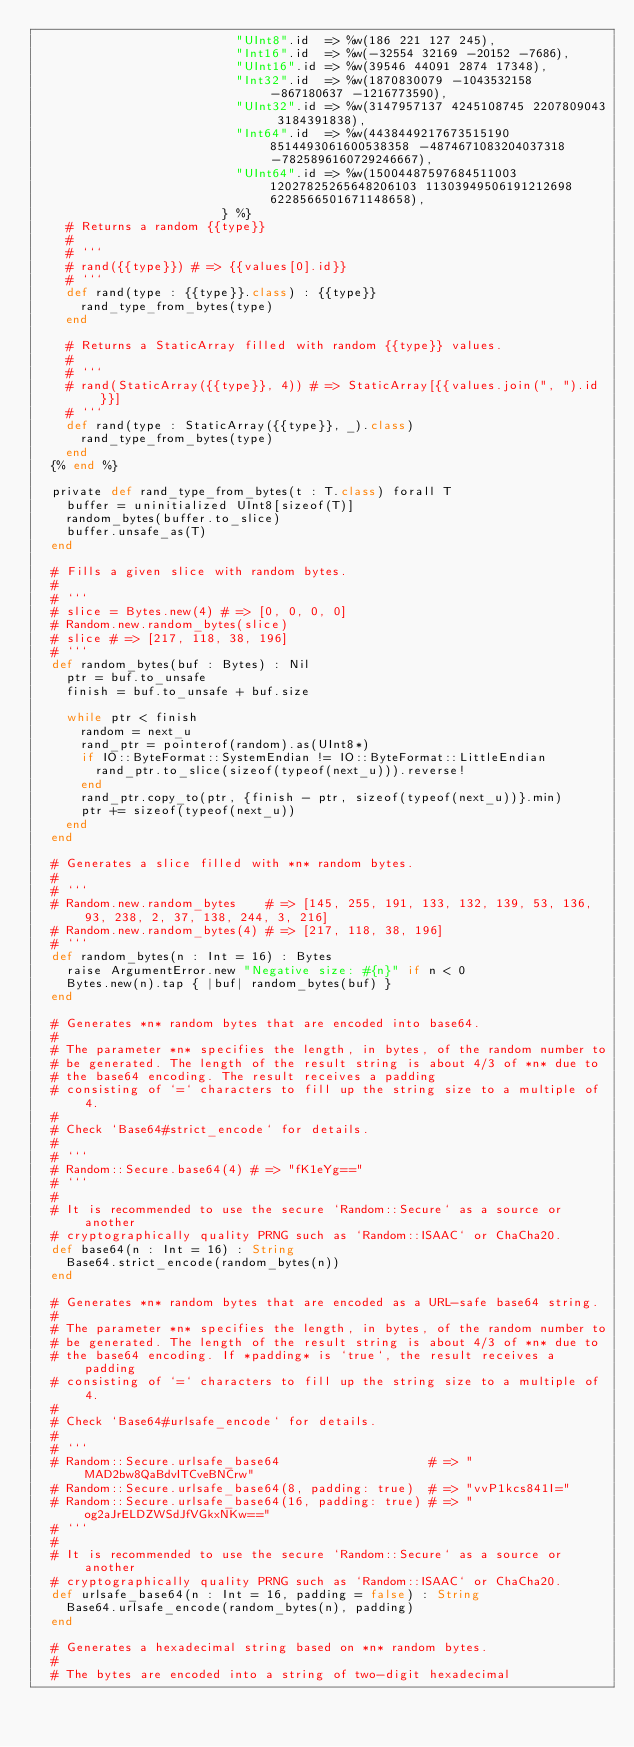<code> <loc_0><loc_0><loc_500><loc_500><_Crystal_>                           "UInt8".id  => %w(186 221 127 245),
                           "Int16".id  => %w(-32554 32169 -20152 -7686),
                           "UInt16".id => %w(39546 44091 2874 17348),
                           "Int32".id  => %w(1870830079 -1043532158 -867180637 -1216773590),
                           "UInt32".id => %w(3147957137 4245108745 2207809043 3184391838),
                           "Int64".id  => %w(4438449217673515190 8514493061600538358 -4874671083204037318 -7825896160729246667),
                           "UInt64".id => %w(15004487597684511003 12027825265648206103 11303949506191212698 6228566501671148658),
                         } %}
    # Returns a random {{type}}
    #
    # ```
    # rand({{type}}) # => {{values[0].id}}
    # ```
    def rand(type : {{type}}.class) : {{type}}
      rand_type_from_bytes(type)
    end

    # Returns a StaticArray filled with random {{type}} values.
    #
    # ```
    # rand(StaticArray({{type}}, 4)) # => StaticArray[{{values.join(", ").id}}]
    # ```
    def rand(type : StaticArray({{type}}, _).class)
      rand_type_from_bytes(type)
    end
  {% end %}

  private def rand_type_from_bytes(t : T.class) forall T
    buffer = uninitialized UInt8[sizeof(T)]
    random_bytes(buffer.to_slice)
    buffer.unsafe_as(T)
  end

  # Fills a given slice with random bytes.
  #
  # ```
  # slice = Bytes.new(4) # => [0, 0, 0, 0]
  # Random.new.random_bytes(slice)
  # slice # => [217, 118, 38, 196]
  # ```
  def random_bytes(buf : Bytes) : Nil
    ptr = buf.to_unsafe
    finish = buf.to_unsafe + buf.size

    while ptr < finish
      random = next_u
      rand_ptr = pointerof(random).as(UInt8*)
      if IO::ByteFormat::SystemEndian != IO::ByteFormat::LittleEndian
        rand_ptr.to_slice(sizeof(typeof(next_u))).reverse!
      end
      rand_ptr.copy_to(ptr, {finish - ptr, sizeof(typeof(next_u))}.min)
      ptr += sizeof(typeof(next_u))
    end
  end

  # Generates a slice filled with *n* random bytes.
  #
  # ```
  # Random.new.random_bytes    # => [145, 255, 191, 133, 132, 139, 53, 136, 93, 238, 2, 37, 138, 244, 3, 216]
  # Random.new.random_bytes(4) # => [217, 118, 38, 196]
  # ```
  def random_bytes(n : Int = 16) : Bytes
    raise ArgumentError.new "Negative size: #{n}" if n < 0
    Bytes.new(n).tap { |buf| random_bytes(buf) }
  end

  # Generates *n* random bytes that are encoded into base64.
  #
  # The parameter *n* specifies the length, in bytes, of the random number to
  # be generated. The length of the result string is about 4/3 of *n* due to
  # the base64 encoding. The result receives a padding
  # consisting of `=` characters to fill up the string size to a multiple of 4.
  #
  # Check `Base64#strict_encode` for details.
  #
  # ```
  # Random::Secure.base64(4) # => "fK1eYg=="
  # ```
  #
  # It is recommended to use the secure `Random::Secure` as a source or another
  # cryptographically quality PRNG such as `Random::ISAAC` or ChaCha20.
  def base64(n : Int = 16) : String
    Base64.strict_encode(random_bytes(n))
  end

  # Generates *n* random bytes that are encoded as a URL-safe base64 string.
  #
  # The parameter *n* specifies the length, in bytes, of the random number to
  # be generated. The length of the result string is about 4/3 of *n* due to
  # the base64 encoding. If *padding* is `true`, the result receives a padding
  # consisting of `=` characters to fill up the string size to a multiple of 4.
  #
  # Check `Base64#urlsafe_encode` for details.
  #
  # ```
  # Random::Secure.urlsafe_base64                    # => "MAD2bw8QaBdvITCveBNCrw"
  # Random::Secure.urlsafe_base64(8, padding: true)  # => "vvP1kcs841I="
  # Random::Secure.urlsafe_base64(16, padding: true) # => "og2aJrELDZWSdJfVGkxNKw=="
  # ```
  #
  # It is recommended to use the secure `Random::Secure` as a source or another
  # cryptographically quality PRNG such as `Random::ISAAC` or ChaCha20.
  def urlsafe_base64(n : Int = 16, padding = false) : String
    Base64.urlsafe_encode(random_bytes(n), padding)
  end

  # Generates a hexadecimal string based on *n* random bytes.
  #
  # The bytes are encoded into a string of two-digit hexadecimal</code> 